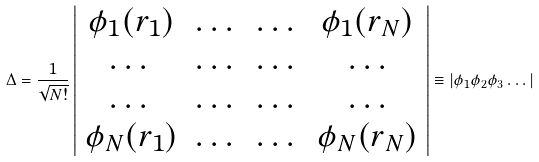<formula> <loc_0><loc_0><loc_500><loc_500>\Delta = \frac { 1 } { \sqrt { N ! } } \left | \begin{array} { c c c c } \phi _ { 1 } ( r _ { 1 } ) & \dots & \dots & \phi _ { 1 } ( r _ { N } ) \\ \dots & \dots & \dots & \dots \\ \dots & \dots & \dots & \dots \\ \phi _ { N } ( r _ { 1 } ) & \dots & \dots & \phi _ { N } ( r _ { N } ) \end{array} \right | \equiv | \phi _ { 1 } \phi _ { 2 } \phi _ { 3 } \dots |</formula> 